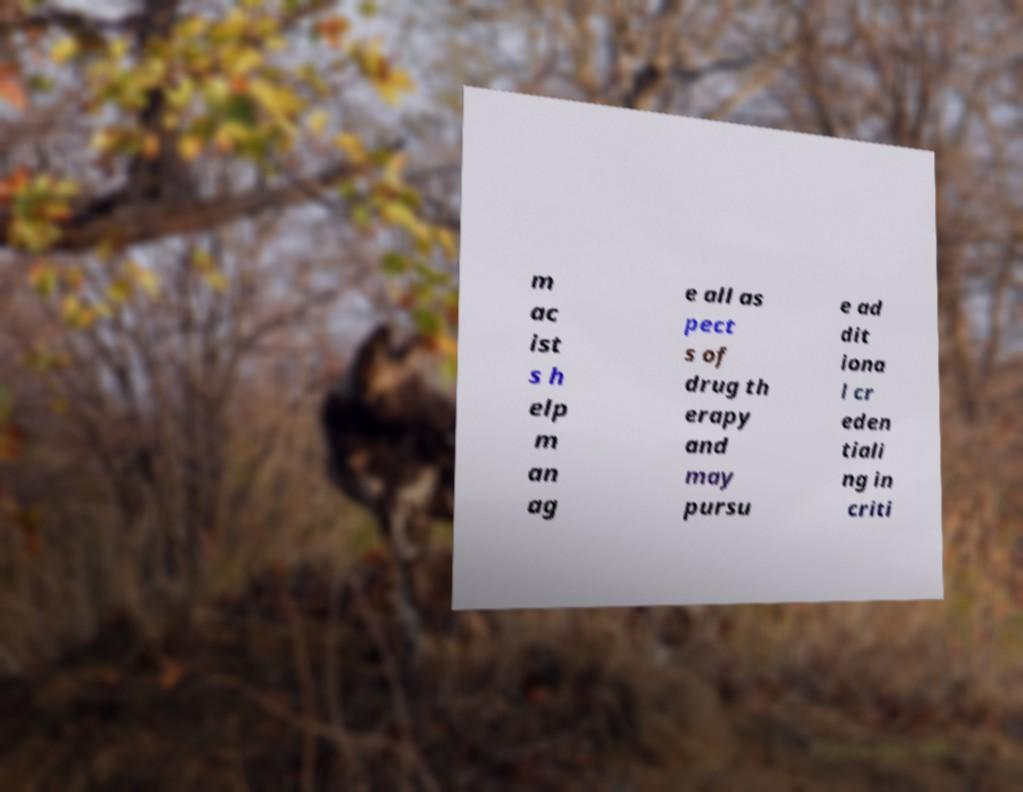What messages or text are displayed in this image? I need them in a readable, typed format. m ac ist s h elp m an ag e all as pect s of drug th erapy and may pursu e ad dit iona l cr eden tiali ng in criti 